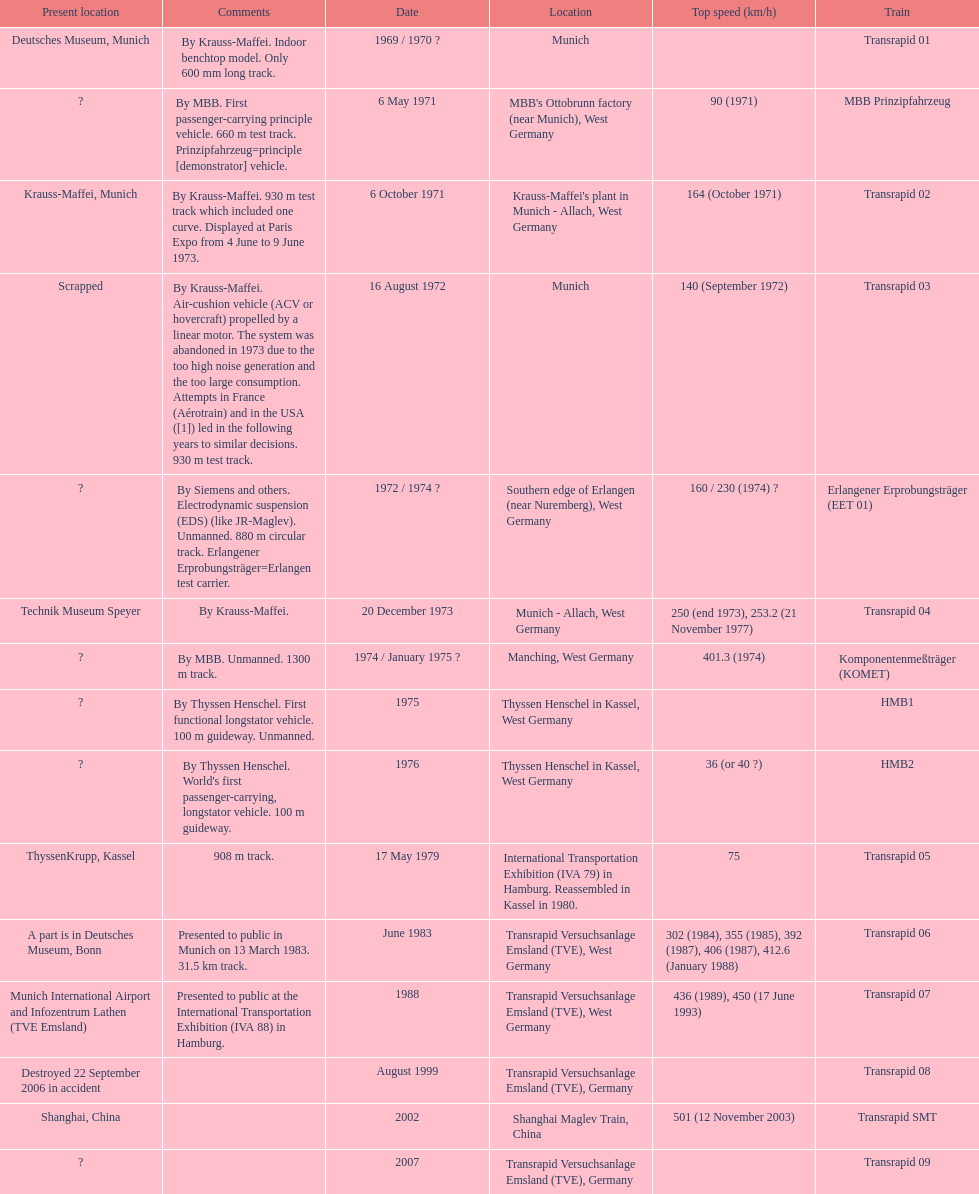Which train has the least top speed? HMB2. 